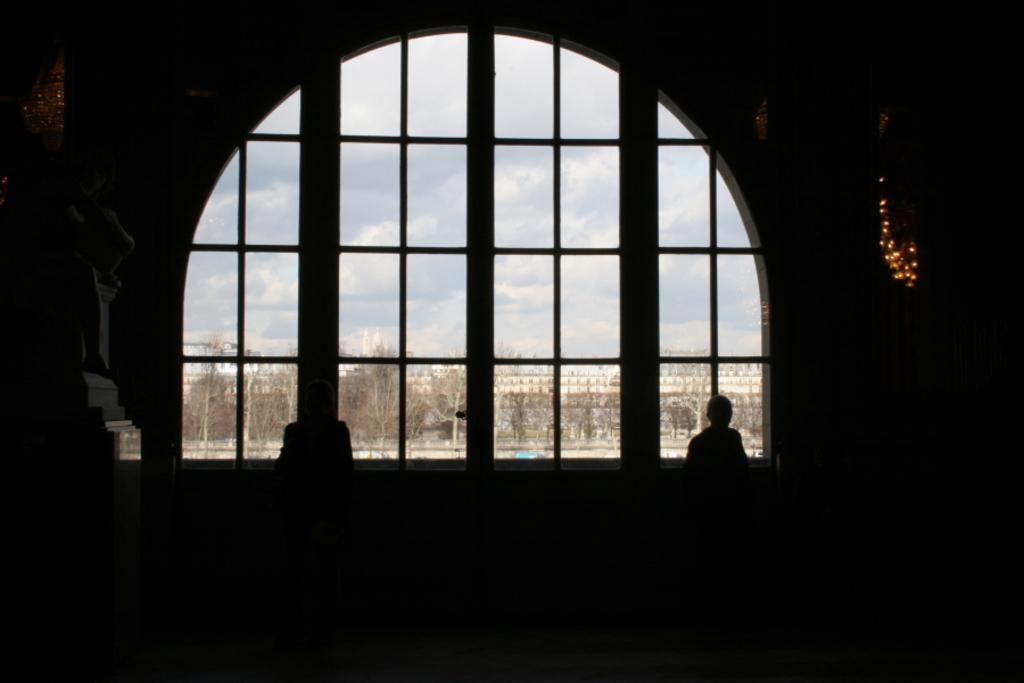Describe this image in one or two sentences. In this image in the center there is a window and through the window we could see some trees and buildings. And there is one person and some objects and the foreground is dark. 